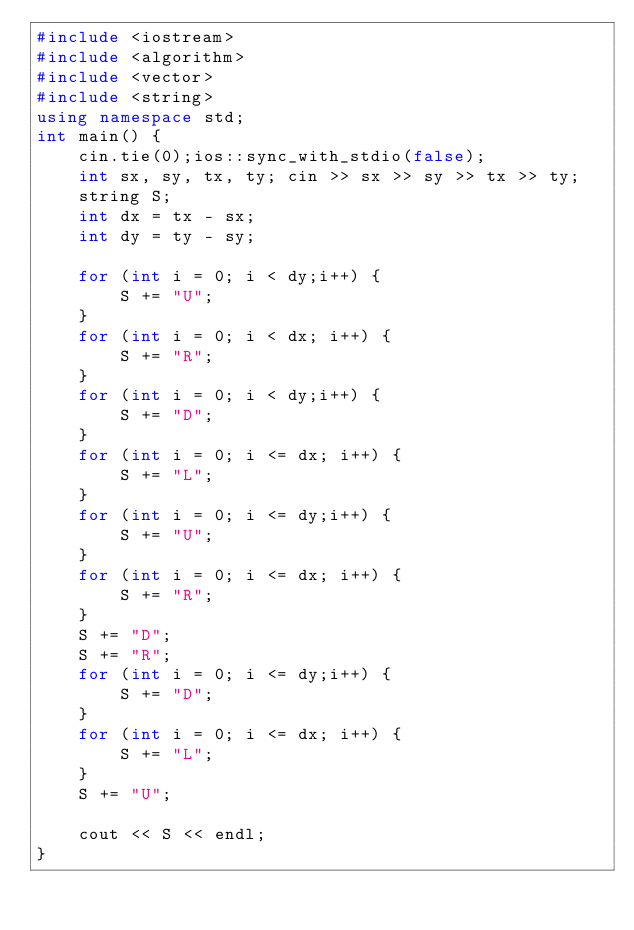Convert code to text. <code><loc_0><loc_0><loc_500><loc_500><_C++_>#include <iostream>
#include <algorithm>
#include <vector>
#include <string>
using namespace std;
int main() {
	cin.tie(0);ios::sync_with_stdio(false);
	int sx, sy, tx, ty; cin >> sx >> sy >> tx >> ty;
	string S;
	int dx = tx - sx;
	int dy = ty - sy;
 
	for (int i = 0; i < dy;i++) {
		S += "U";
	}
	for (int i = 0; i < dx; i++) {
		S += "R";
	}
	for (int i = 0; i < dy;i++) {
		S += "D";
	}
	for (int i = 0; i <= dx; i++) {
		S += "L";
	}
	for (int i = 0; i <= dy;i++) {
		S += "U";
	}
	for (int i = 0; i <= dx; i++) {
		S += "R";
	}
	S += "D";
	S += "R";
	for (int i = 0; i <= dy;i++) {
		S += "D";
	}
	for (int i = 0; i <= dx; i++) {
		S += "L";
	}
	S += "U";

	cout << S << endl;
}</code> 